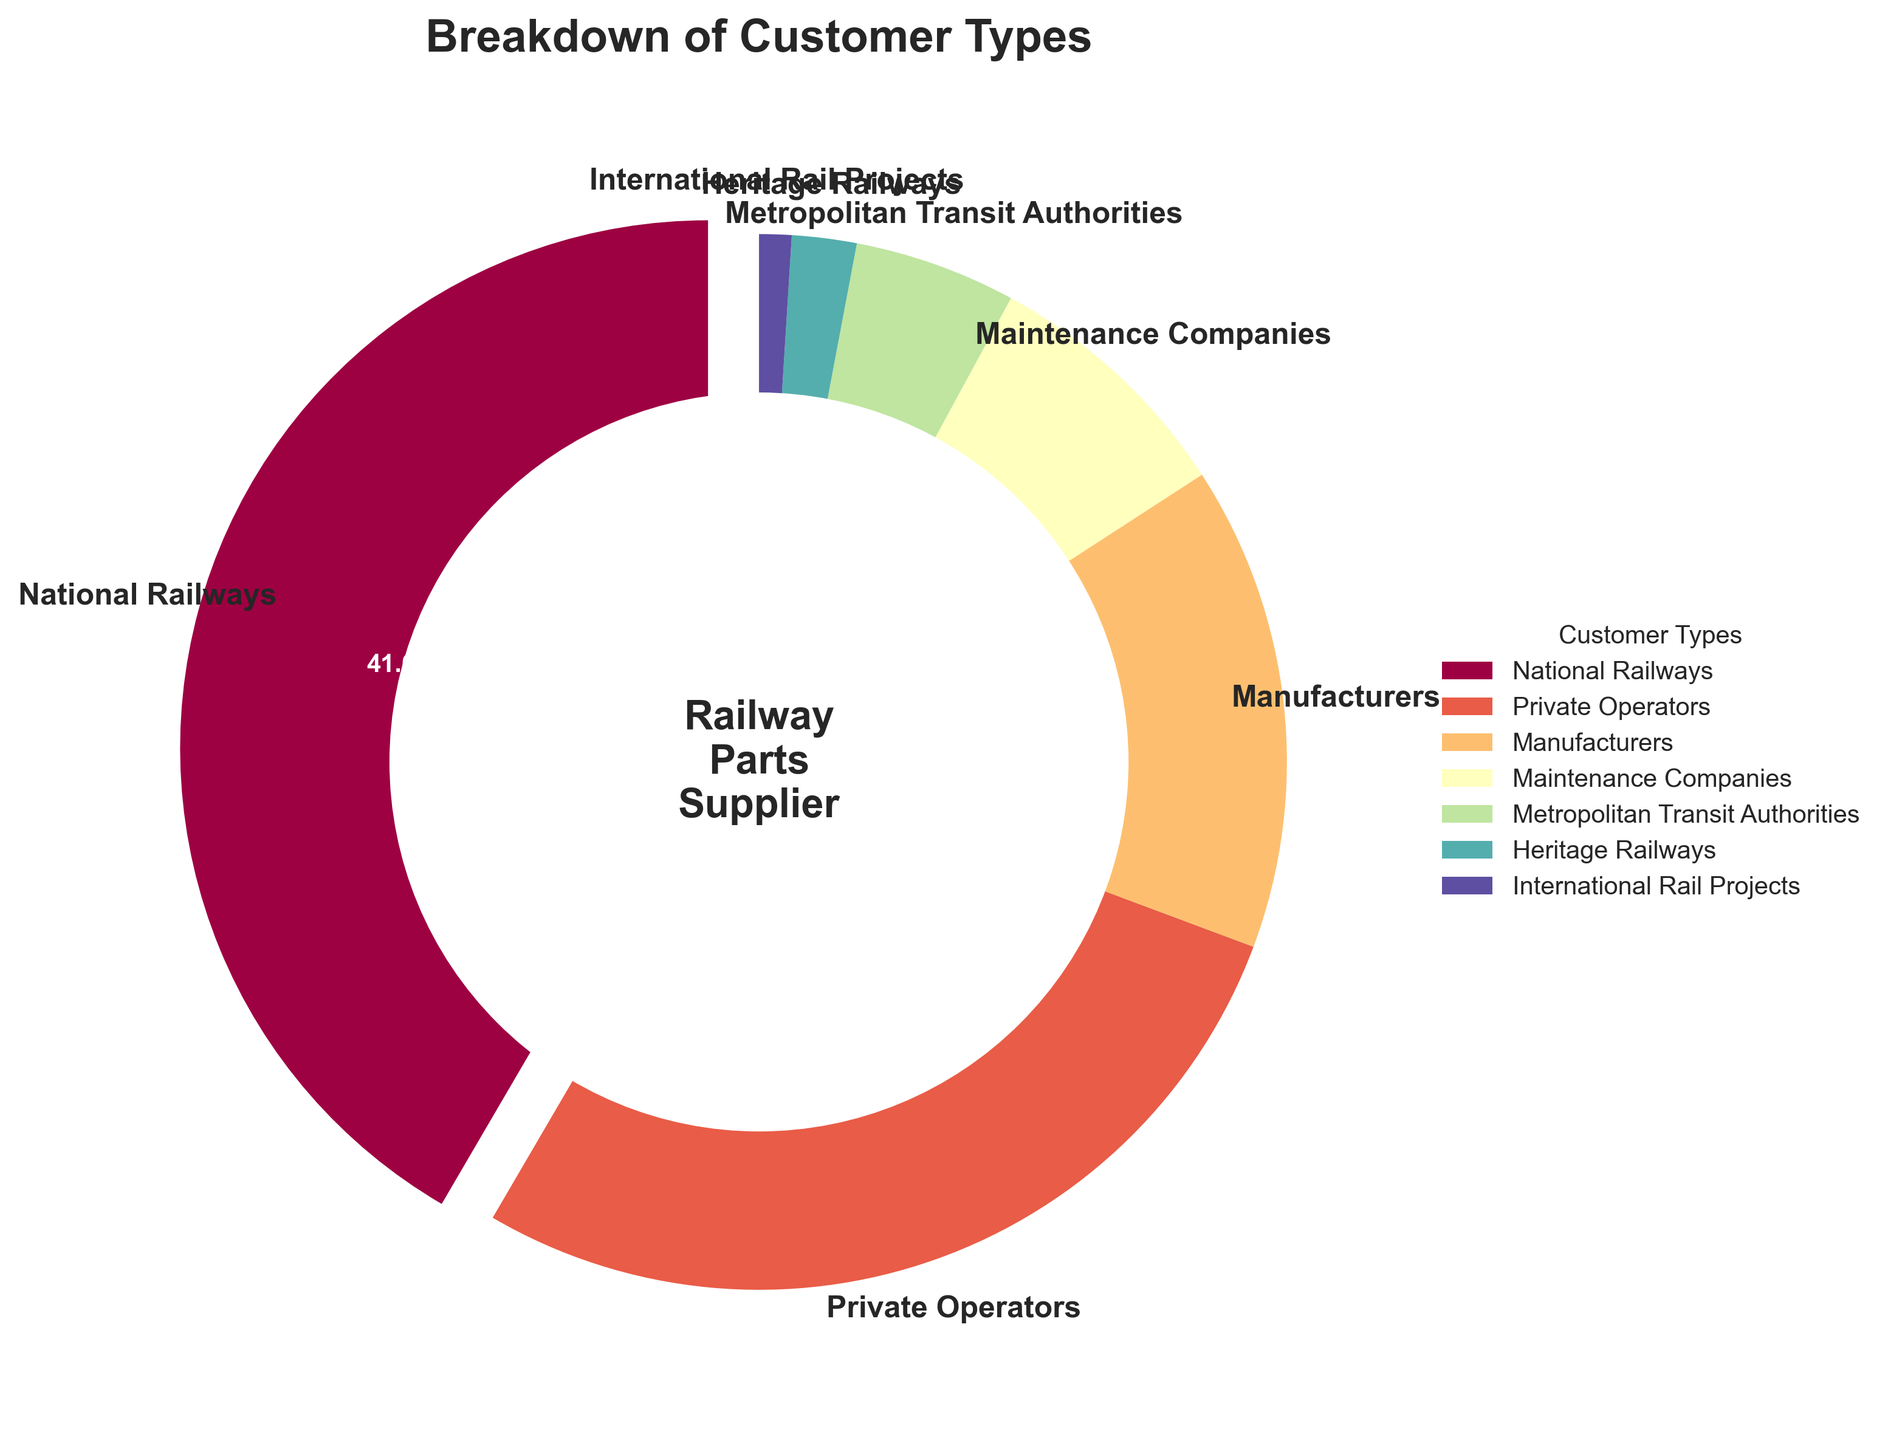What percentage do private operators represent? According to the pie chart, private operators have a specific segment labeled with their respective percentage value.
Answer: 28% Which customer type has the smallest percentage share? By examining the pie chart, Heritage Railways has the smallest segment, indicating the smallest percentage share.
Answer: Heritage Railways What percentage of the market is represented by national railways and metropolitan transit authorities combined? Add the percentages for national railways (42%) and metropolitan transit authorities (5%). The combined percentage is 42% + 5% = 47%.
Answer: 47% How much larger is the national railways segment compared to manufacturers? Subtract the manufacturers' percentage (15%) from national railways' percentage (42%). The difference is 42% - 15% = 27%.
Answer: 27% Which customer type segments together represent more than 50% of the pie chart? National Railways (42%) and Private Operators (28%) together represent more than 50%, specifically 42% + 28% = 70%.
Answer: National Railways and Private Operators What is the percentage difference between maintenance companies and metropolitan transit authorities? Subtract the percentage of metropolitan transit authorities (5%) from maintenance companies (8%). The difference is 8% - 5% = 3%.
Answer: 3% Rank the customer types from highest to lowest percentage. List the customer types according to their percentage values in descending order: National Railways (42%), Private Operators (28%), Manufacturers (15%), Maintenance Companies (8%), Metropolitan Transit Authorities (5%), Heritage Railways (2%), International Rail Projects (1%).
Answer: National Railways, Private Operators, Manufacturers, Maintenance Companies, Metropolitan Transit Authorities, Heritage Railways, International Rail Projects What percentage do the maintenance companies and heritage railways together represent, and how does it compare to manufacturers? Maintenance companies (8%) and heritage railways (2%) together represent 10% (8% + 2%). This is less compared to manufacturers (15%). Therefore, the combined percentage of maintenance companies and heritage railways (10%) is lower than that of manufacturers (15%).
Answer: 10%, less than manufacturers 